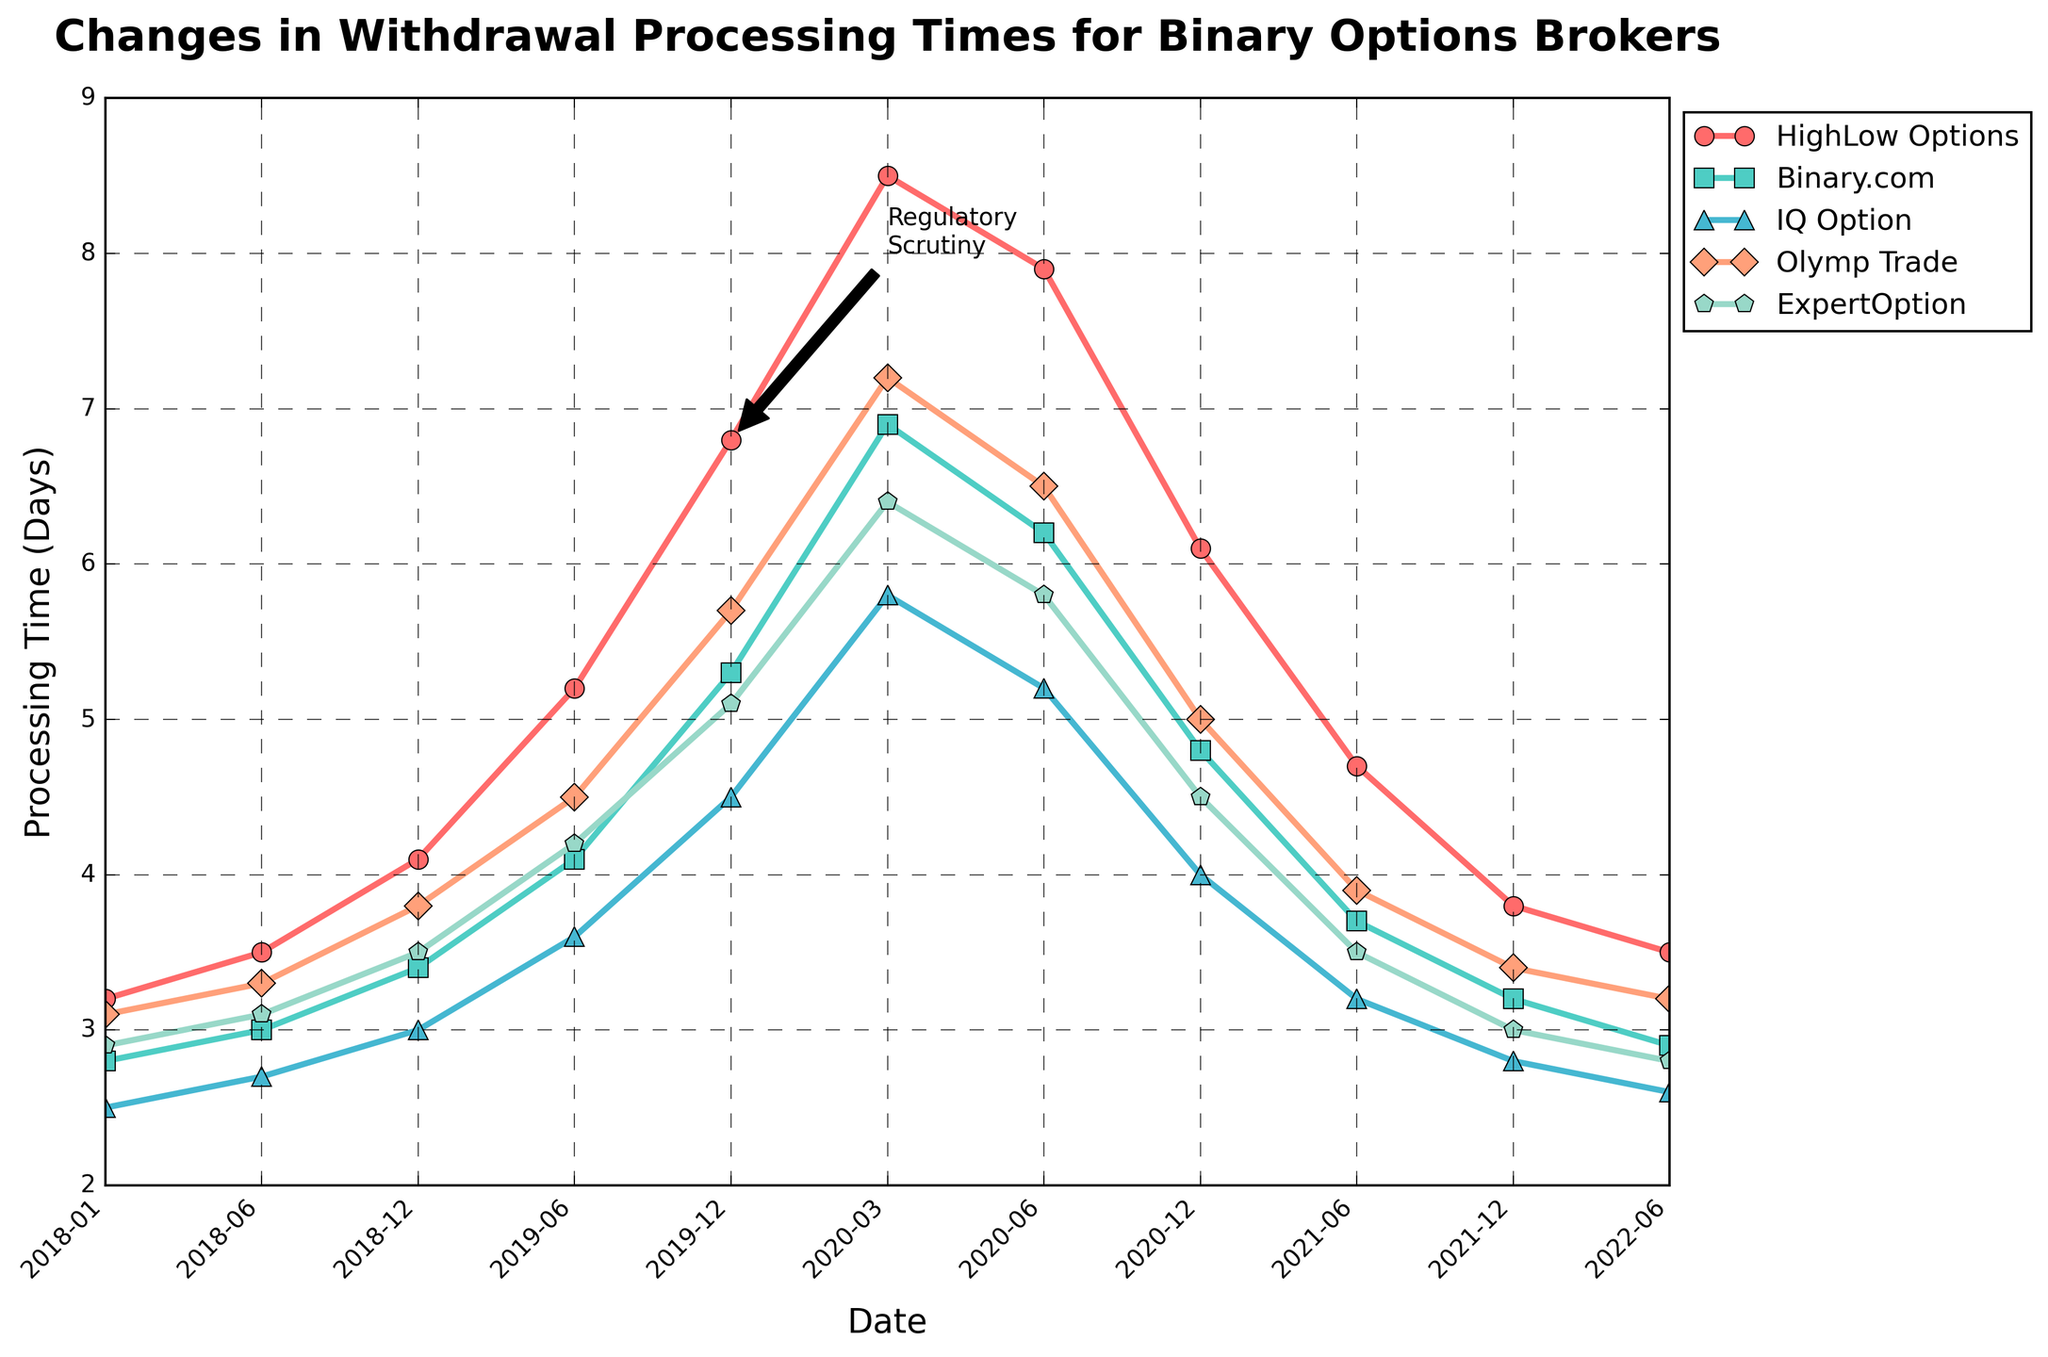What is the general trend in withdrawal processing times for HighLow Options from 2018 to 2022? The chart shows an initial increase from 3.2 days in January 2018 to a peak of 8.5 days in March 2020, followed by a decrease to 3.5 days by June 2022.
Answer: Increased then decreased Which broker had the highest withdrawal processing time in December 2019? In December 2019, HighLow Options had the highest processing time at 6.8 days, as indicated by the red line at the highest point.
Answer: HighLow Options By how much did Olymp Trade's withdrawal processing time change from June 2019 to December 2020? In June 2019, Olymp Trade's processing time was 4.5 days. By December 2020, it decreased to 5.0 days. The change is 4.5 - 5.0 = -0.5 days.
Answer: Decreased by 0.5 days Compare the withdrawal processing times of IQ Option and Binary.com in March 2020. Which one was higher and by how much? In March 2020, IQ Option had a processing time of 5.8 days, while Binary.com had 6.9 days. The difference is 6.9 - 5.8 = 1.1 days, with Binary.com being higher.
Answer: Binary.com by 1.1 days Did ExpertOption's processing time ever exceed 6 days? The highest point for ExpertOption is 6.4 days in March 2020, indicating that it did exceed 6 days.
Answer: Yes What is the overall pattern observed for all brokers' processing times post-regulatory scrutiny (post-June 2019)? Post-June 2019, processing times for all brokers initially rose, peaking around March 2020, followed by a notable decrease towards June 2022.
Answer: Rose then decreased Which broker showed the most significant decrease in processing times from March 2020 to December 2020? HighLow Options decreased from 8.5 to 6.1, Binary.com from 6.9 to 4.8, IQ Option from 5.8 to 4.0, Olymp Trade from 7.2 to 5.0, and ExpertOption from 6.4 to 4.5. The largest decrease is HighLow Options: 8.5 - 6.1 = 2.4 days.
Answer: HighLow Options What was the trend for Binary.com's processing time from June 2019 to June 2021? Binary.com's processing time increased from 4.1 days in June 2019 to 6.9 days in March 2020, then steadily decreased to 3.7 days by June 2021.
Answer: Increased then decreased Compare the processing times of HighLow Options and ExpertOption in June 2021. Which one was lower and by how much? In June 2021, HighLow Options had a processing time of 4.7 days, while ExpertOption had 3.5 days. The difference is 4.7 - 3.5 = 1.2 days with ExpertOption being lower.
Answer: ExpertOption by 1.2 days 